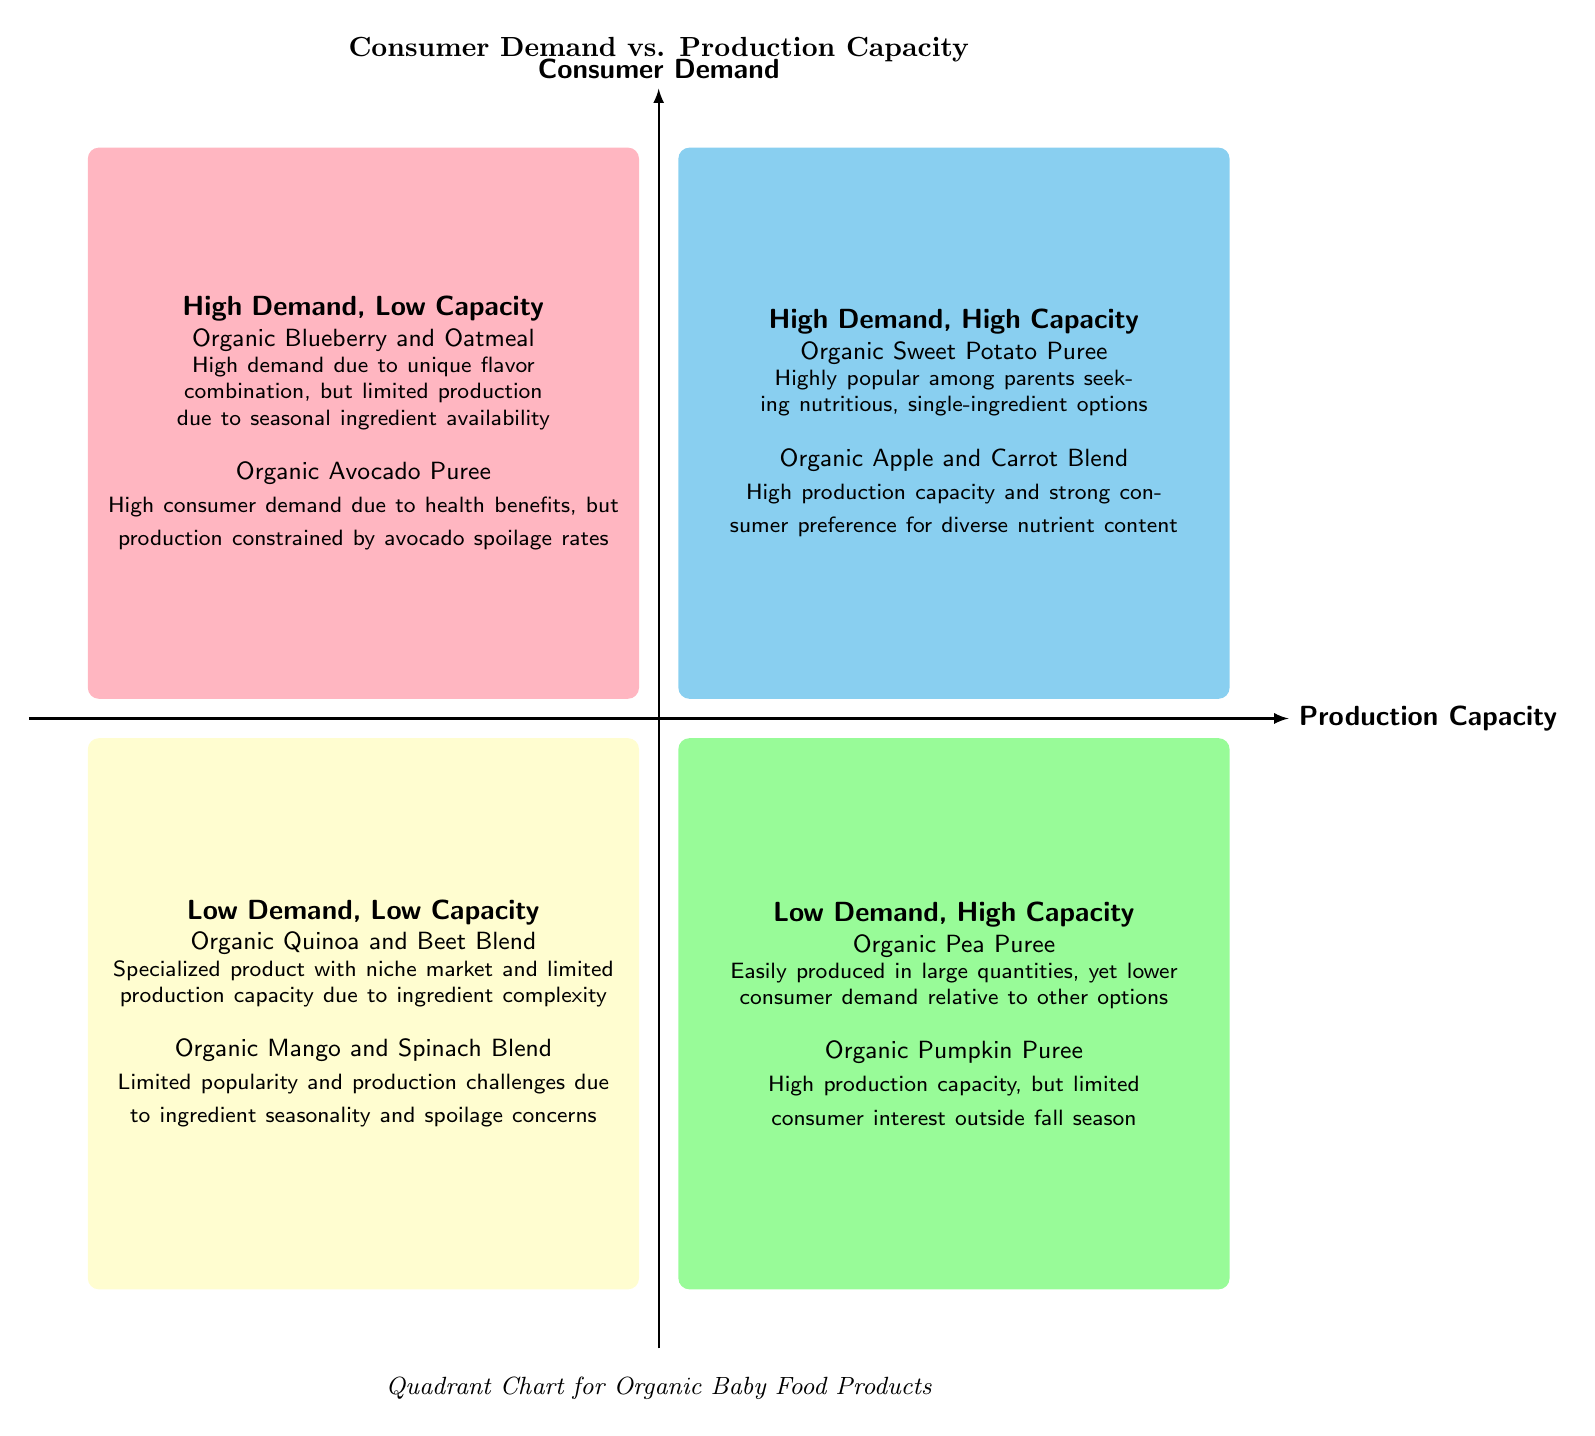What products are in the High Demand, High Capacity quadrant? The diagram indicates that the products listed in the High Demand, High Capacity quadrant are "Organic Sweet Potato Puree" and "Organic Apple and Carrot Blend".
Answer: Organic Sweet Potato Puree, Organic Apple and Carrot Blend How many products are there in the Low Demand, High Capacity quadrant? By examining the Low Demand, High Capacity quadrant, we can see there are two products listed: "Organic Pea Puree" and "Organic Pumpkin Puree".
Answer: 2 Which quadrant contains the Organic Blueberry and Oatmeal? The Organic Blueberry and Oatmeal is located in the High Demand, Low Capacity quadrant according to the provided data in the diagram.
Answer: High Demand, Low Capacity What is the general consumer demand for Organic Quinoa and Beet Blend? The diagram categorizes Organic Quinoa and Beet Blend in the Low Demand, Low Capacity quadrant, indicating it has limited consumer demand.
Answer: Low demand In which quadrant would you find products with limited popularity but high production capacity? Products with limited popularity but high production capacity can be found in the Low Demand, High Capacity quadrant, as evidenced by the examples given in that section.
Answer: Low Demand, High Capacity Why is Organic Avocado Puree categorized in the High Demand, Low Capacity quadrant? Organic Avocado Puree is categorized in the High Demand, Low Capacity quadrant because there is high consumer demand for it due to its health benefits, but its production is constrained by spoilage rates.
Answer: High Demand, Low Capacity What is the production capacity status of Organic Pumpkin Puree according to the diagram? The diagram indicates that Organic Pumpkin Puree has high production capacity but limited consumer interest, placing it in the Low Demand, High Capacity quadrant.
Answer: High production capacity Which product has high demand with seasonal ingredient availability limitations? The product that has high demand due to its unique flavor combination but is limited in production due to seasonal ingredient availability is Organic Blueberry and Oatmeal, as stated in the High Demand, Low Capacity quadrant.
Answer: Organic Blueberry and Oatmeal 